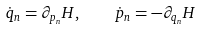<formula> <loc_0><loc_0><loc_500><loc_500>\dot { q } _ { n } = \partial _ { p _ { n } } H , \quad \dot { p } _ { n } = - \partial _ { q _ { n } } H</formula> 